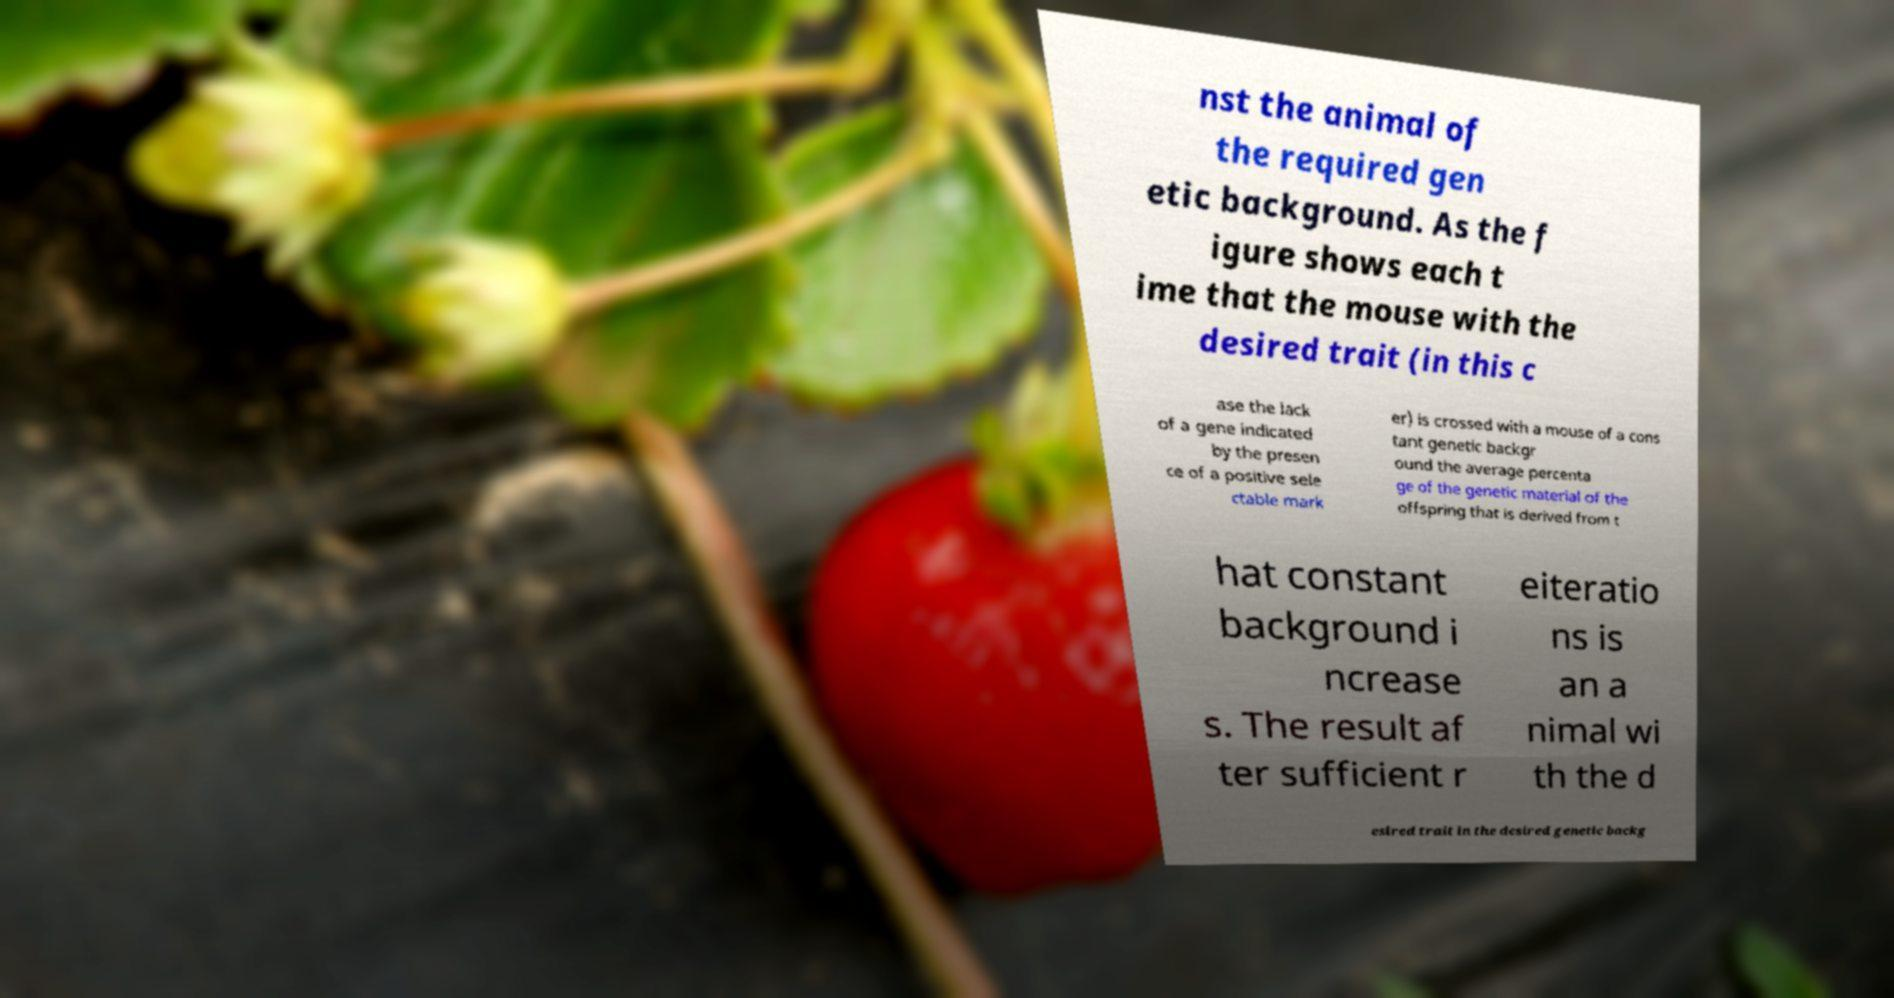I need the written content from this picture converted into text. Can you do that? nst the animal of the required gen etic background. As the f igure shows each t ime that the mouse with the desired trait (in this c ase the lack of a gene indicated by the presen ce of a positive sele ctable mark er) is crossed with a mouse of a cons tant genetic backgr ound the average percenta ge of the genetic material of the offspring that is derived from t hat constant background i ncrease s. The result af ter sufficient r eiteratio ns is an a nimal wi th the d esired trait in the desired genetic backg 